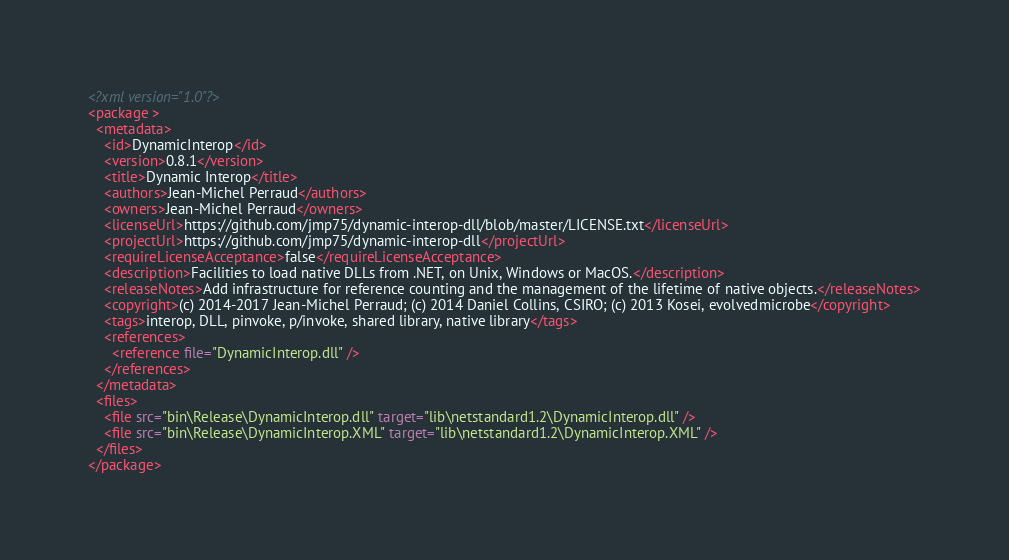<code> <loc_0><loc_0><loc_500><loc_500><_XML_><?xml version="1.0"?>
<package >
  <metadata>
    <id>DynamicInterop</id>
    <version>0.8.1</version>
    <title>Dynamic Interop</title>
    <authors>Jean-Michel Perraud</authors>
    <owners>Jean-Michel Perraud</owners>
    <licenseUrl>https://github.com/jmp75/dynamic-interop-dll/blob/master/LICENSE.txt</licenseUrl>
    <projectUrl>https://github.com/jmp75/dynamic-interop-dll</projectUrl>
    <requireLicenseAcceptance>false</requireLicenseAcceptance>
    <description>Facilities to load native DLLs from .NET, on Unix, Windows or MacOS.</description>
    <releaseNotes>Add infrastructure for reference counting and the management of the lifetime of native objects.</releaseNotes>
    <copyright>(c) 2014-2017 Jean-Michel Perraud; (c) 2014 Daniel Collins, CSIRO; (c) 2013 Kosei, evolvedmicrobe</copyright>
    <tags>interop, DLL, pinvoke, p/invoke, shared library, native library</tags>
    <references>
      <reference file="DynamicInterop.dll" />
    </references>
  </metadata>
  <files>
    <file src="bin\Release\DynamicInterop.dll" target="lib\netstandard1.2\DynamicInterop.dll" />
    <file src="bin\Release\DynamicInterop.XML" target="lib\netstandard1.2\DynamicInterop.XML" />
  </files>
</package>
</code> 